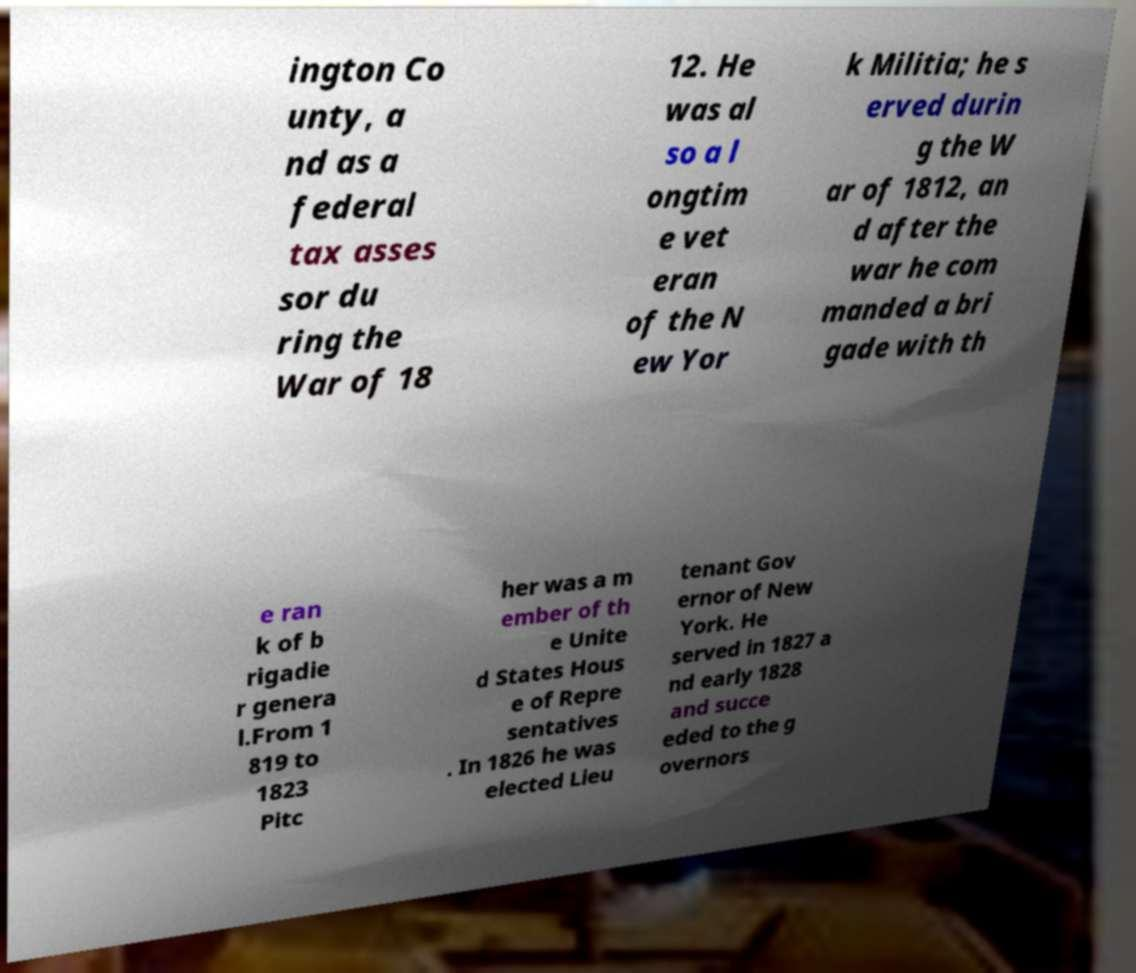What messages or text are displayed in this image? I need them in a readable, typed format. ington Co unty, a nd as a federal tax asses sor du ring the War of 18 12. He was al so a l ongtim e vet eran of the N ew Yor k Militia; he s erved durin g the W ar of 1812, an d after the war he com manded a bri gade with th e ran k of b rigadie r genera l.From 1 819 to 1823 Pitc her was a m ember of th e Unite d States Hous e of Repre sentatives . In 1826 he was elected Lieu tenant Gov ernor of New York. He served in 1827 a nd early 1828 and succe eded to the g overnors 